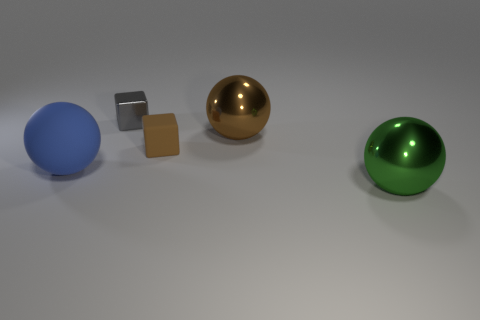Add 4 blue matte spheres. How many objects exist? 9 Subtract all red metal blocks. Subtract all shiny spheres. How many objects are left? 3 Add 4 matte spheres. How many matte spheres are left? 5 Add 3 tiny blue rubber spheres. How many tiny blue rubber spheres exist? 3 Subtract 0 gray spheres. How many objects are left? 5 Subtract all cubes. How many objects are left? 3 